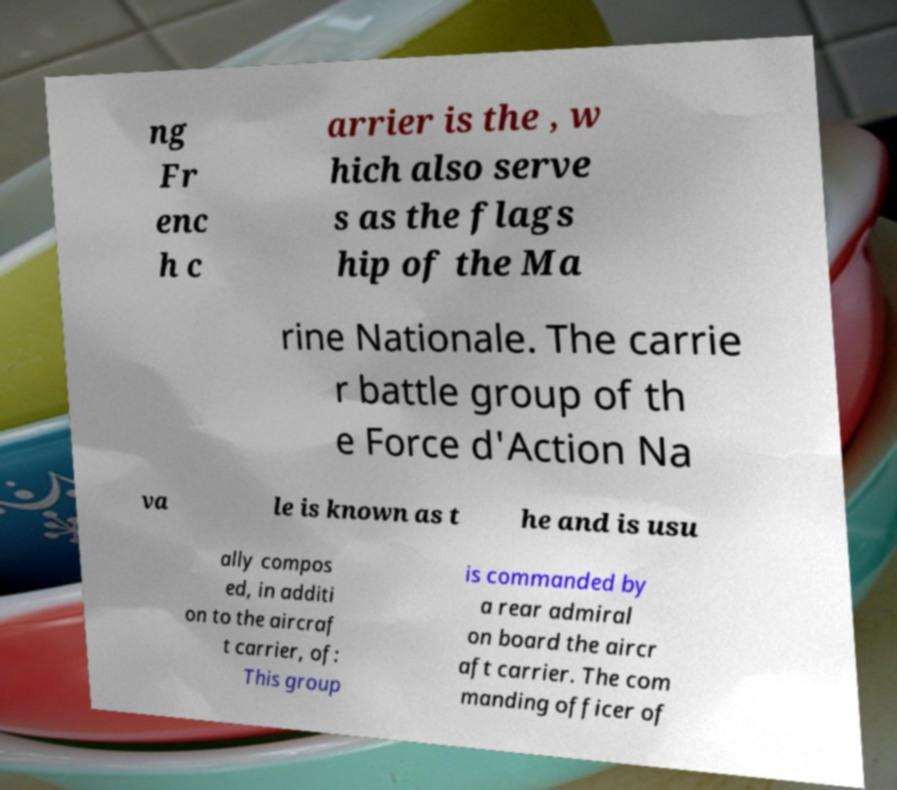Could you assist in decoding the text presented in this image and type it out clearly? ng Fr enc h c arrier is the , w hich also serve s as the flags hip of the Ma rine Nationale. The carrie r battle group of th e Force d'Action Na va le is known as t he and is usu ally compos ed, in additi on to the aircraf t carrier, of: This group is commanded by a rear admiral on board the aircr aft carrier. The com manding officer of 